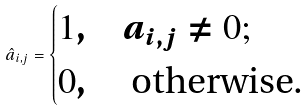Convert formula to latex. <formula><loc_0><loc_0><loc_500><loc_500>\hat { a } _ { i , j } = \begin{cases} 1 , & a _ { i , j } \neq 0 ; \\ 0 , & \text { otherwise. } \end{cases}</formula> 